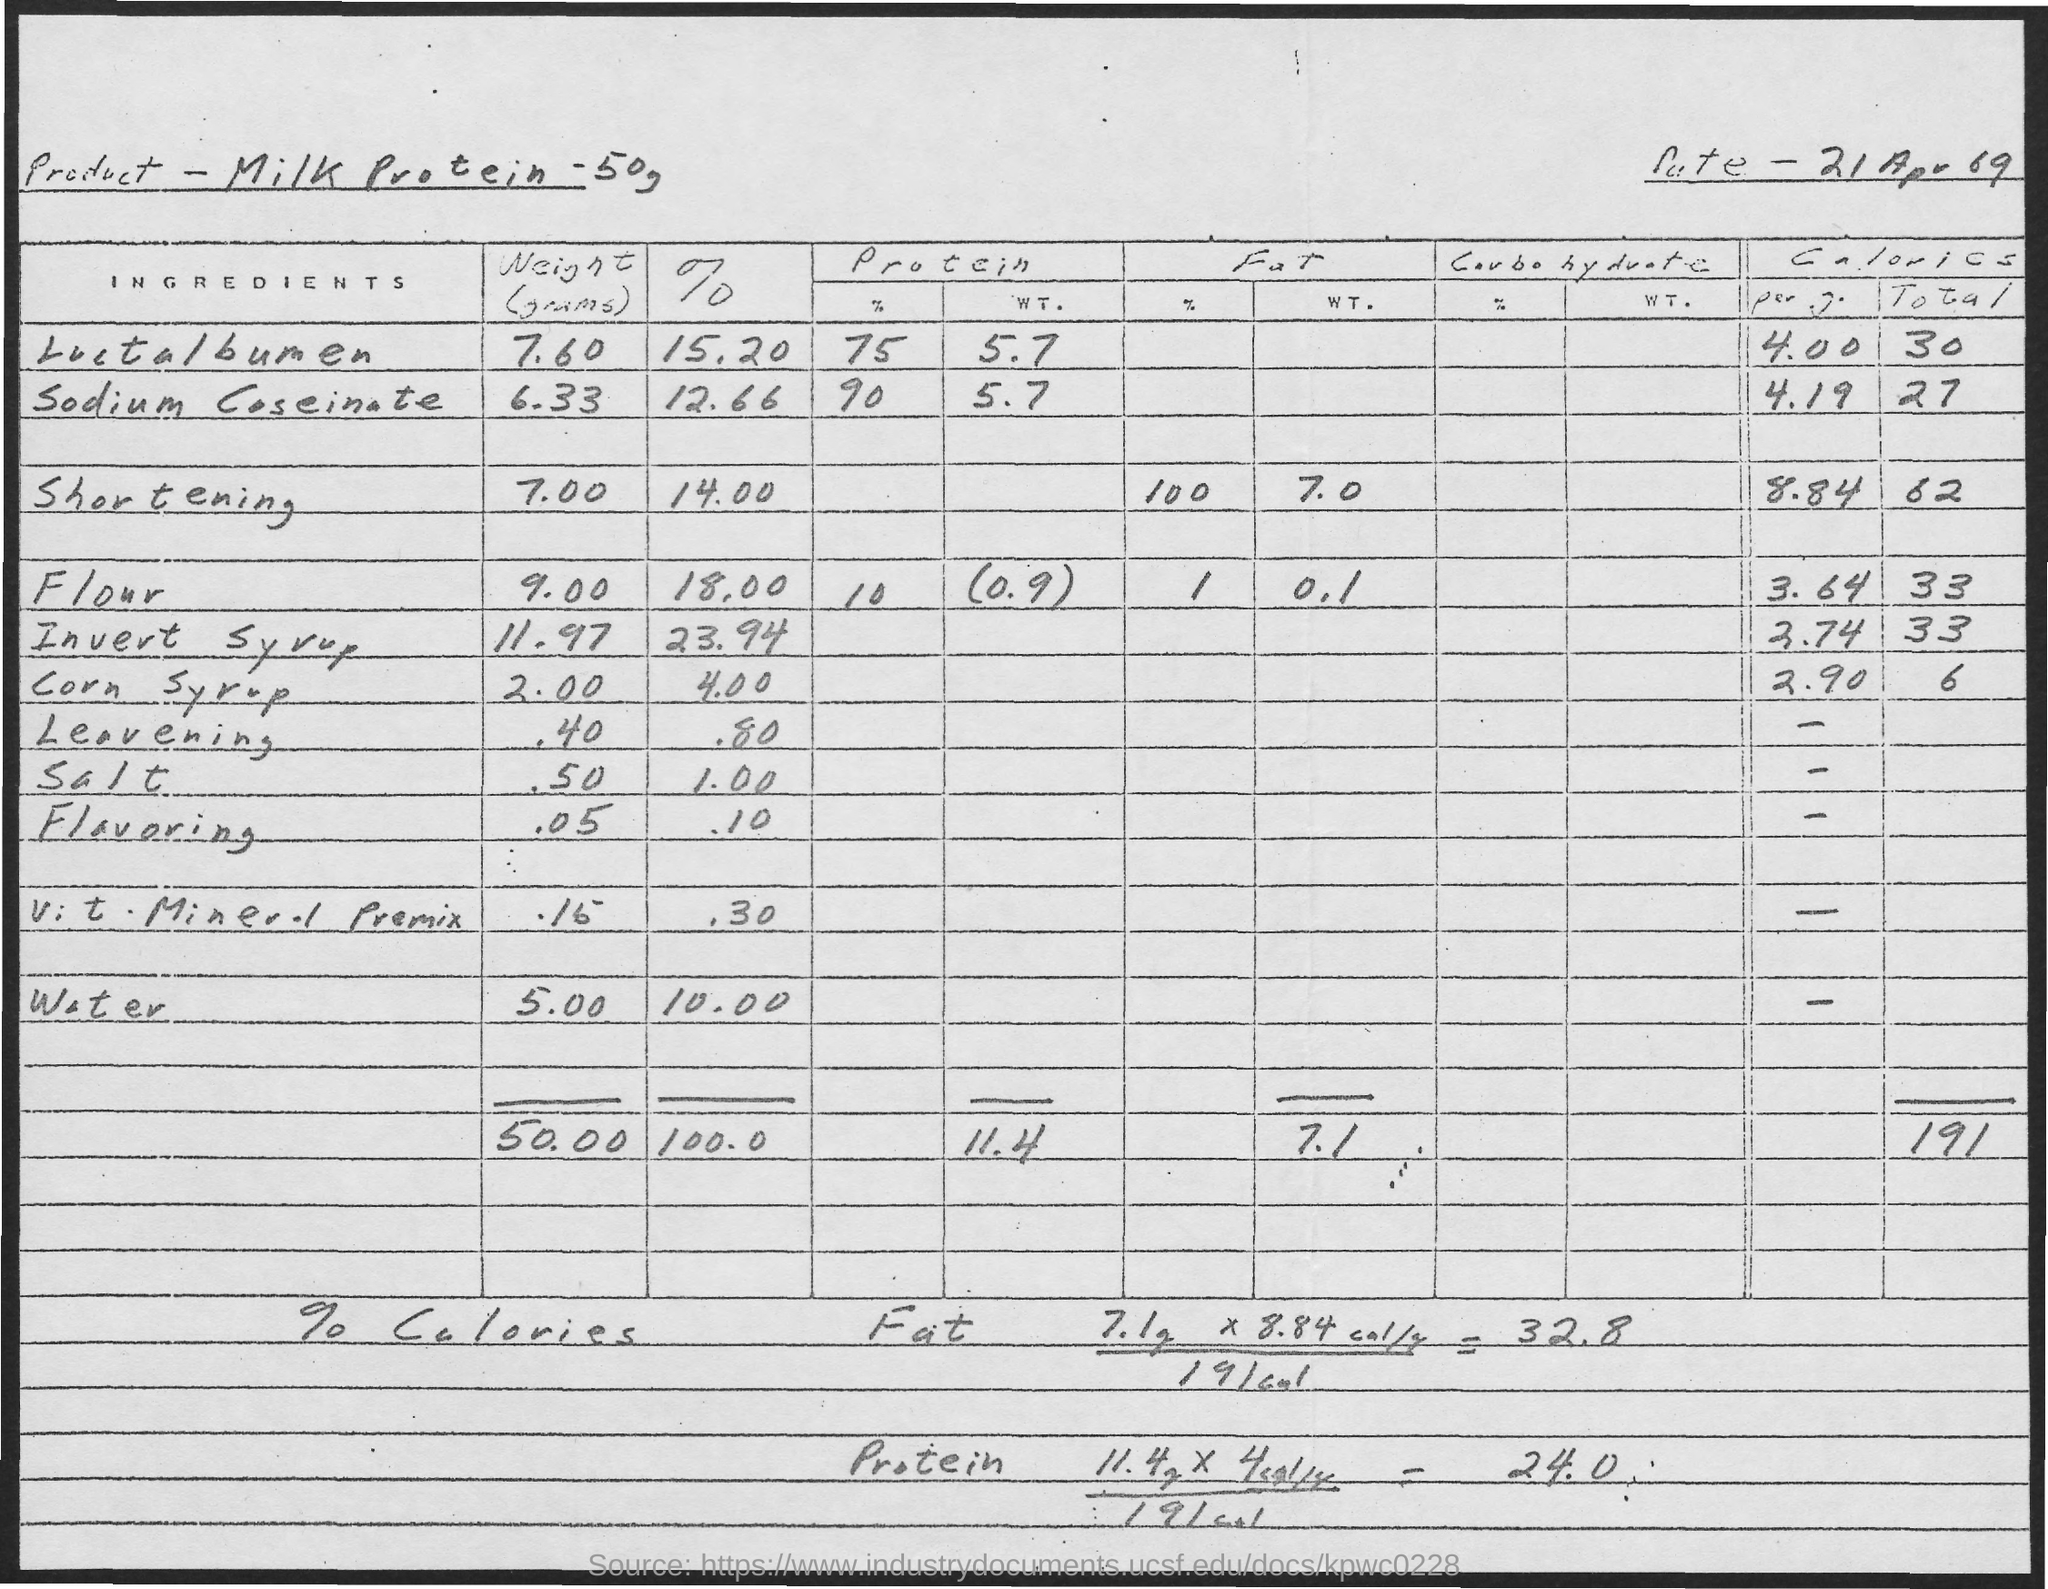Can you tell me more about the purpose of this document? This image displays a handwritten recipe or formula page, possibly from a cookbook or a manufacturing ledger, outlining the quantities and percentages of various ingredients for a product that includes milk protein. Dated 21 April 1969, it seems to focus on the nutritional breakdown, providing detailed information on protein, fat, and carbohydrate contents. 